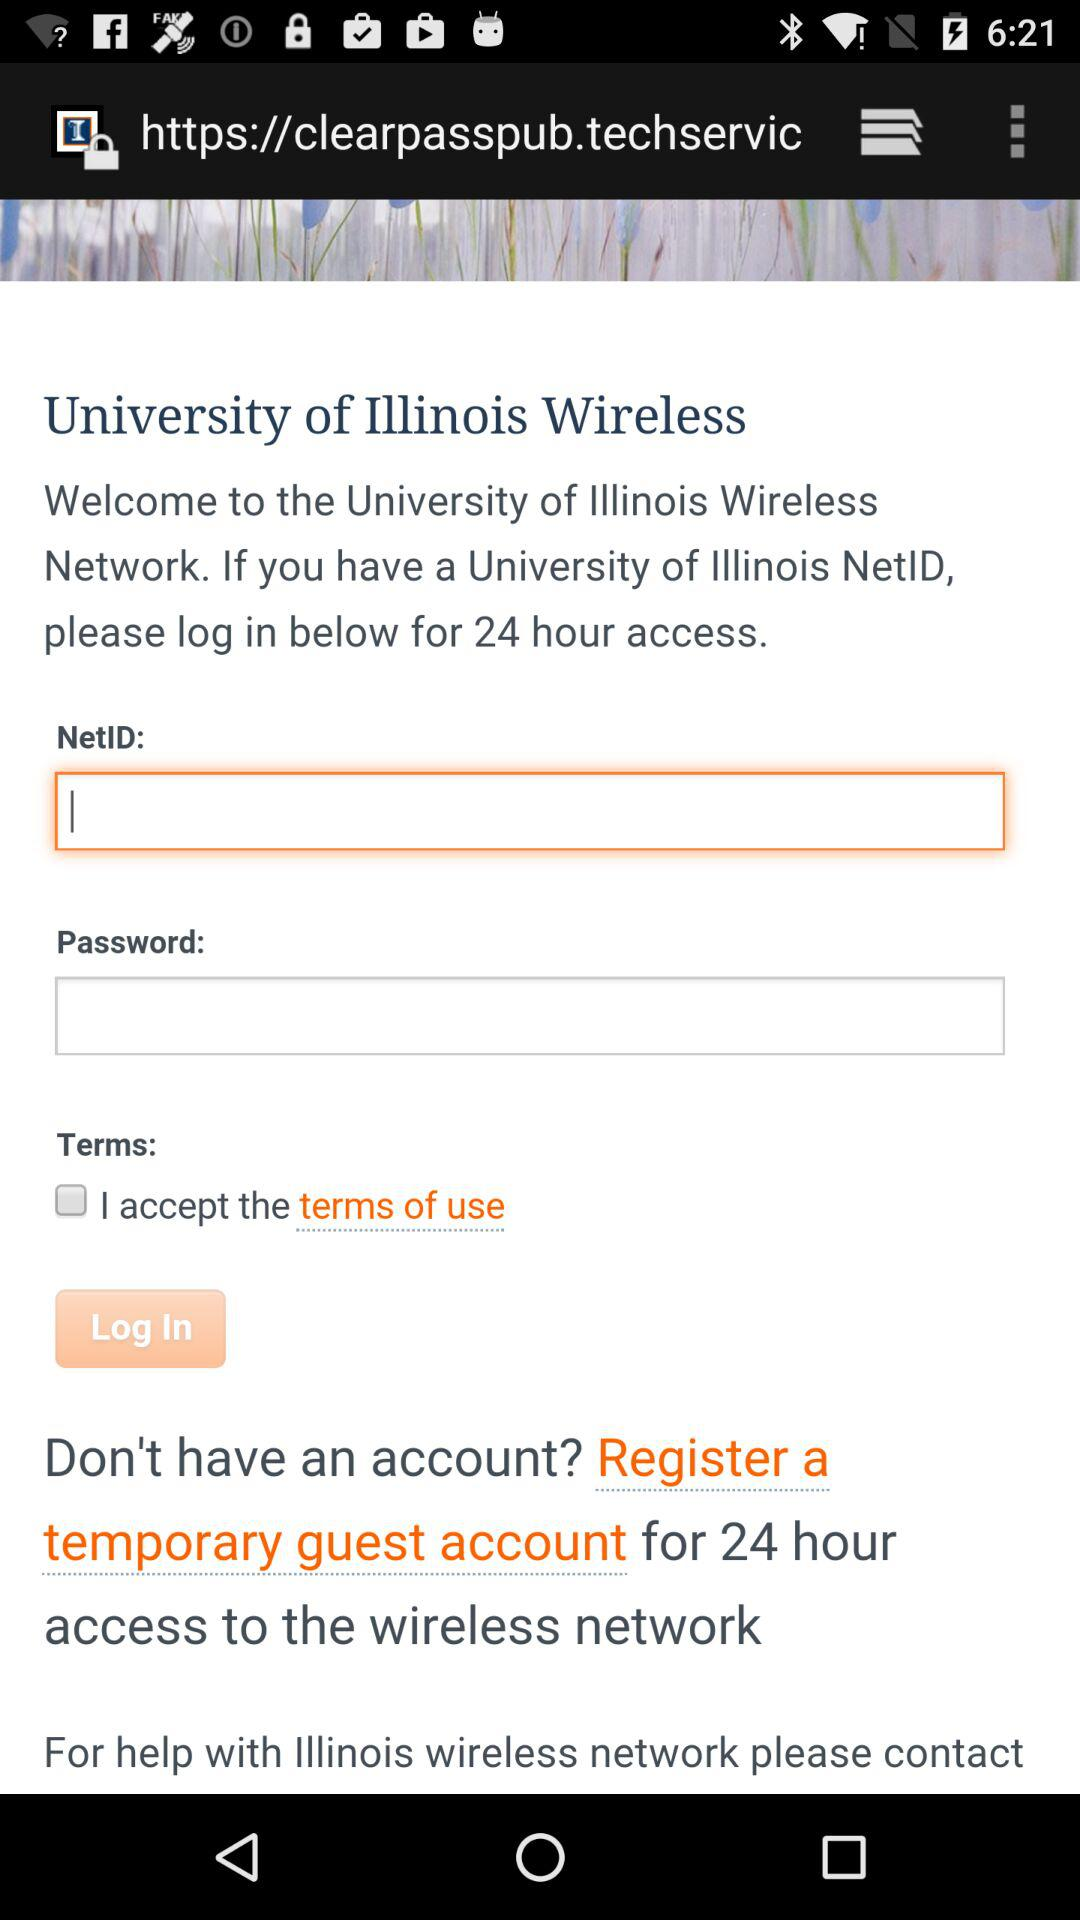What is the name of the university? The name of the university is "University of Illinois Wireless". 